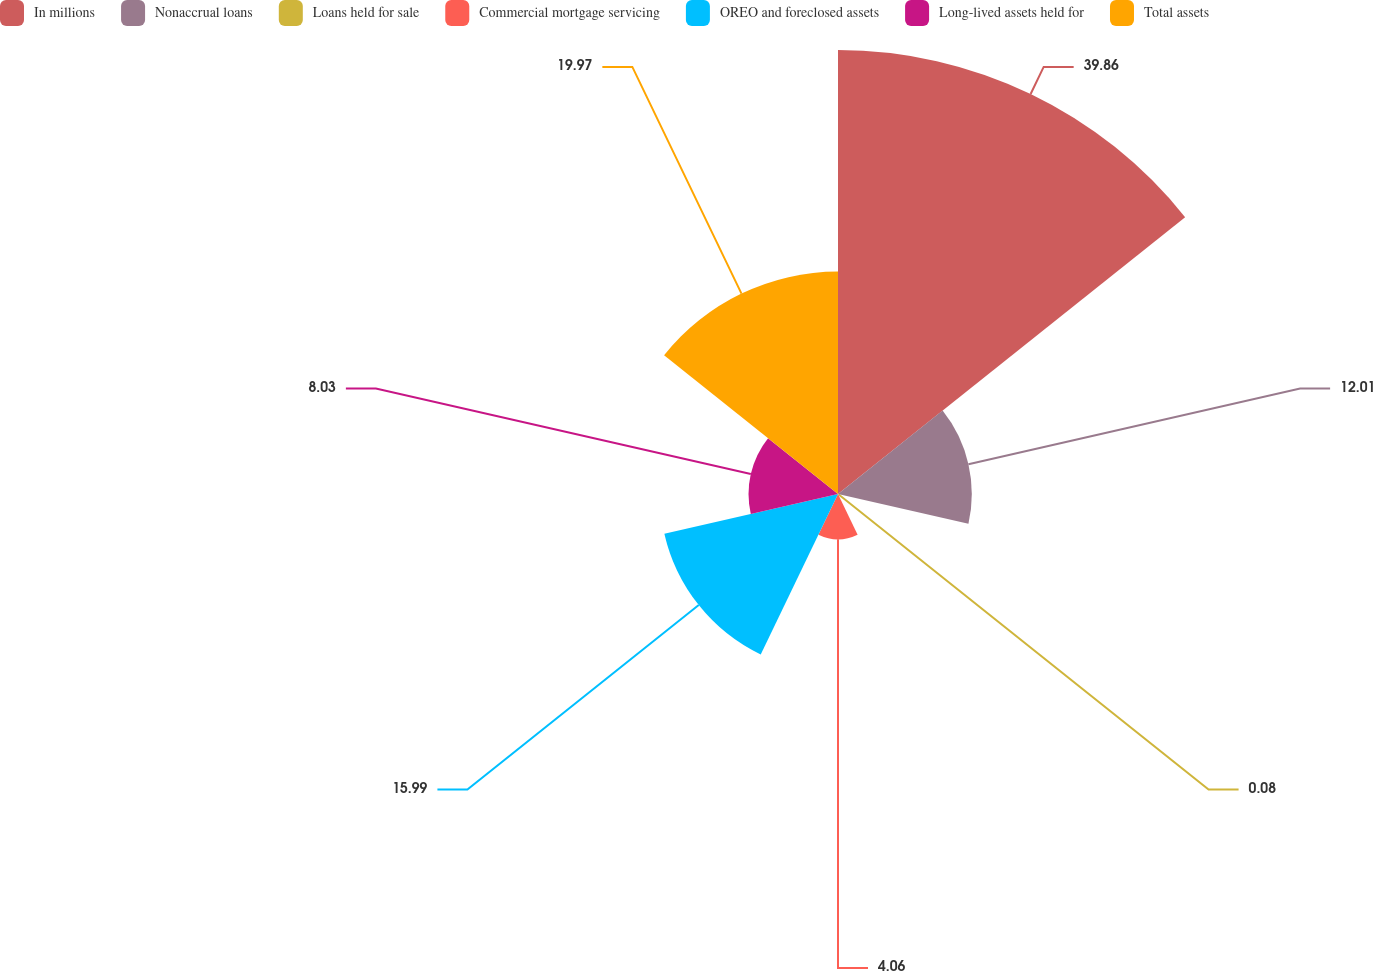<chart> <loc_0><loc_0><loc_500><loc_500><pie_chart><fcel>In millions<fcel>Nonaccrual loans<fcel>Loans held for sale<fcel>Commercial mortgage servicing<fcel>OREO and foreclosed assets<fcel>Long-lived assets held for<fcel>Total assets<nl><fcel>39.86%<fcel>12.01%<fcel>0.08%<fcel>4.06%<fcel>15.99%<fcel>8.03%<fcel>19.97%<nl></chart> 